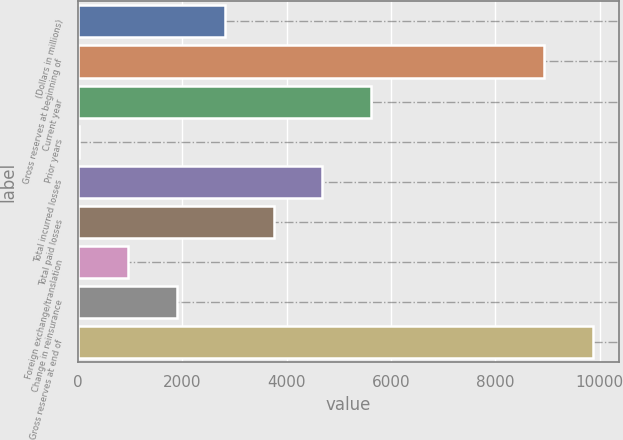Convert chart to OTSL. <chart><loc_0><loc_0><loc_500><loc_500><bar_chart><fcel>(Dollars in millions)<fcel>Gross reserves at beginning of<fcel>Current year<fcel>Prior years<fcel>Total incurred losses<fcel>Total paid losses<fcel>Foreign exchange/translation<fcel>Change in reinsurance<fcel>Gross reserves at end of<nl><fcel>2823.69<fcel>8937.9<fcel>5616.48<fcel>30.9<fcel>4685.55<fcel>3754.62<fcel>961.83<fcel>1892.76<fcel>9868.83<nl></chart> 